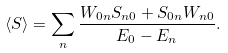<formula> <loc_0><loc_0><loc_500><loc_500>\langle { S } \rangle = \sum _ { n } \frac { W _ { 0 n } { S } _ { n 0 } + { S } _ { 0 n } W _ { n 0 } } { E _ { 0 } - E _ { n } } .</formula> 